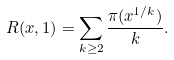Convert formula to latex. <formula><loc_0><loc_0><loc_500><loc_500>R ( x , 1 ) = \sum _ { k \geq 2 } \frac { \pi ( x ^ { 1 / k } ) } { k } .</formula> 